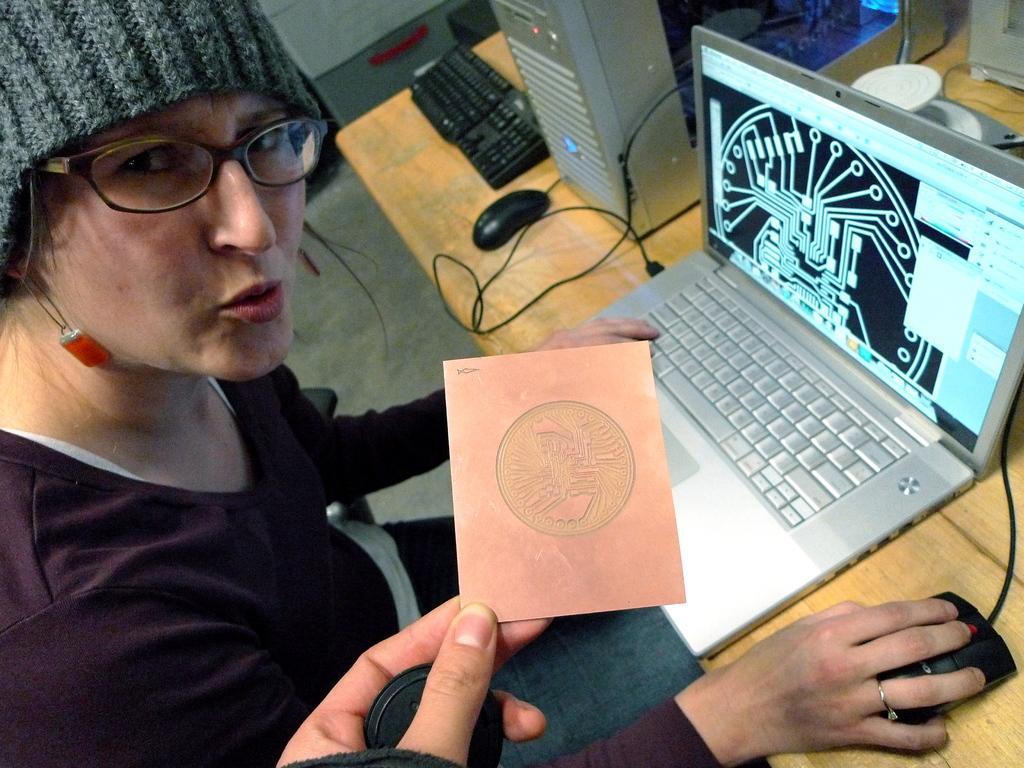How would you summarize this image in a sentence or two? In front of the image there is some object held in a person's hand, behind that there is a woman sitting in the chair, in front of the woman on the table there is a laptop, mouse, CPU, keyboard, cables and some other objects, beside the table there is some other object. 